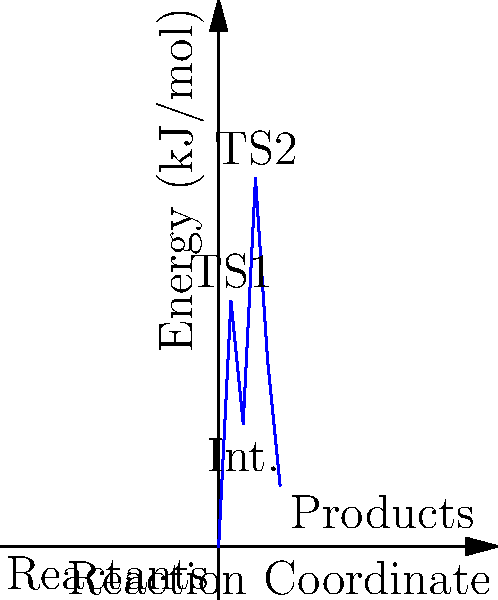Based on the energy profile diagram of a novel catalytic reaction, what is the rate-determining step, and how does it affect the overall reaction rate? To determine the rate-determining step and its effect on the overall reaction rate, we need to analyze the energy profile diagram:

1. Identify transition states (TS):
   - TS1 at x=1 with energy ~20 kJ/mol
   - TS2 at x=3 with energy ~30 kJ/mol

2. Compare activation energies:
   - TS1 activation energy: ~20 kJ/mol
   - TS2 activation energy: ~20 kJ/mol (from intermediate to TS2)

3. Identify rate-determining step:
   - The step with the highest activation energy is the rate-determining step
   - TS2 has the highest overall energy barrier (~30 kJ/mol)
   - Therefore, the step involving TS2 is the rate-determining step

4. Effect on overall reaction rate:
   - According to transition state theory, the reaction rate is proportional to $e^{-E_a/RT}$
   - $E_a$ is the activation energy of the rate-determining step
   - Higher $E_a$ leads to a slower reaction rate
   - The overall reaction rate will be primarily controlled by the energy barrier of TS2

5. Conclusion:
   The rate-determining step is the one involving TS2, and it will slow down the overall reaction rate due to its higher activation energy.
Answer: TS2; slows overall reaction rate 